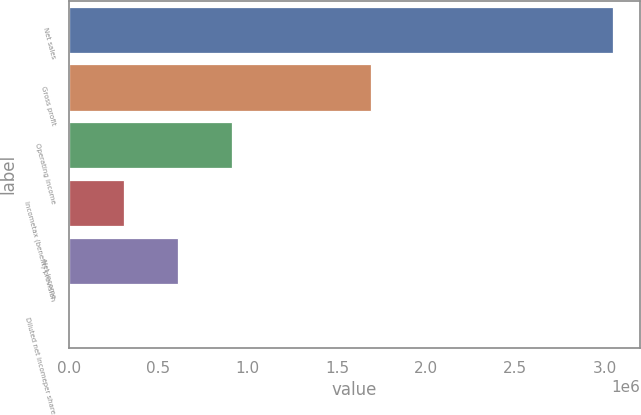<chart> <loc_0><loc_0><loc_500><loc_500><bar_chart><fcel>Net sales<fcel>Gross profit<fcel>Operating income<fcel>Incometax (benefit) provision<fcel>Net income<fcel>Diluted net incomeper share<nl><fcel>3.0458e+06<fcel>1.68852e+06<fcel>913741<fcel>304582<fcel>609162<fcel>2.73<nl></chart> 